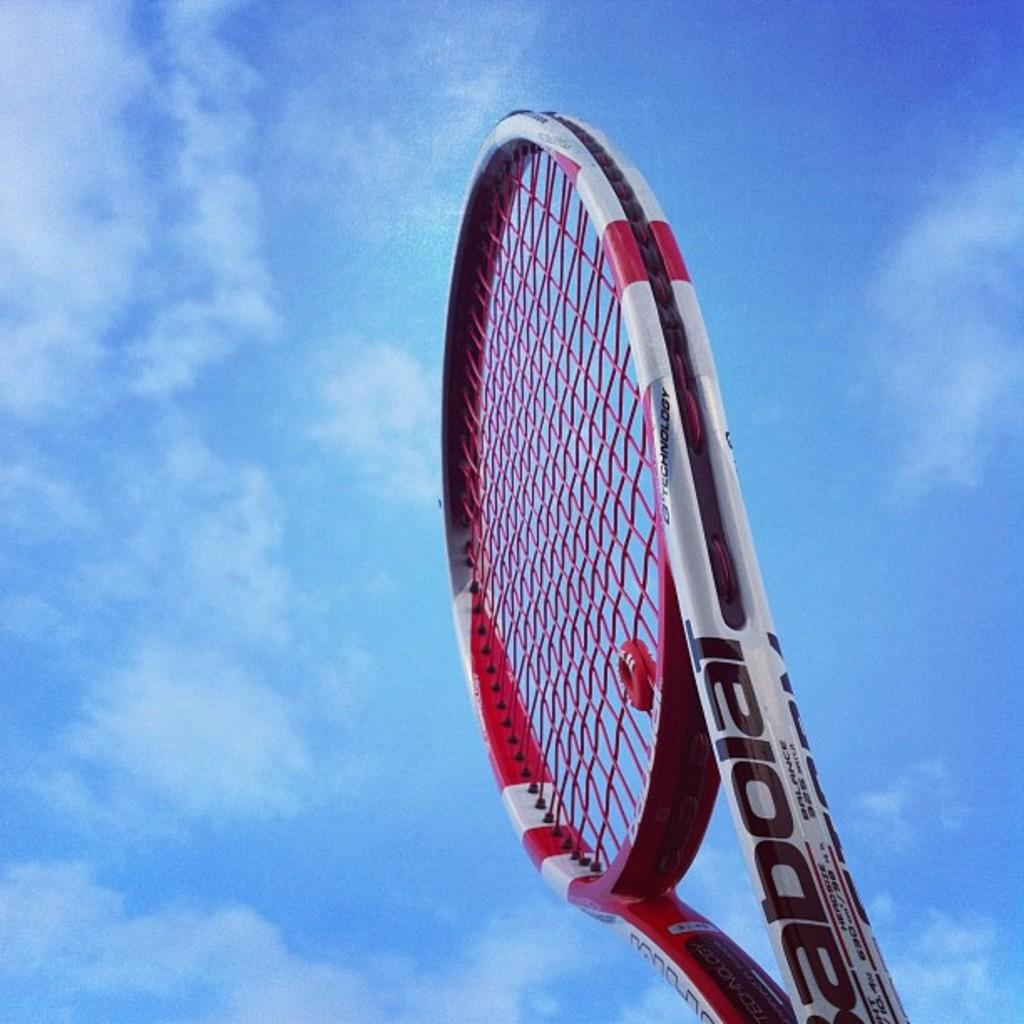What object is the main subject of the image? There is a tennis bat in the image. What colors can be seen on the tennis bat? The tennis bat is white, red, and black in color. What can be seen in the background of the image? The sky is visible in the background of the image. What type of bear can be seen holding a pipe in the image? There is no bear or pipe present in the image; it only features a tennis bat. Is there a seat visible in the image? There is no seat present in the image; it only features a tennis bat and the sky in the background. 